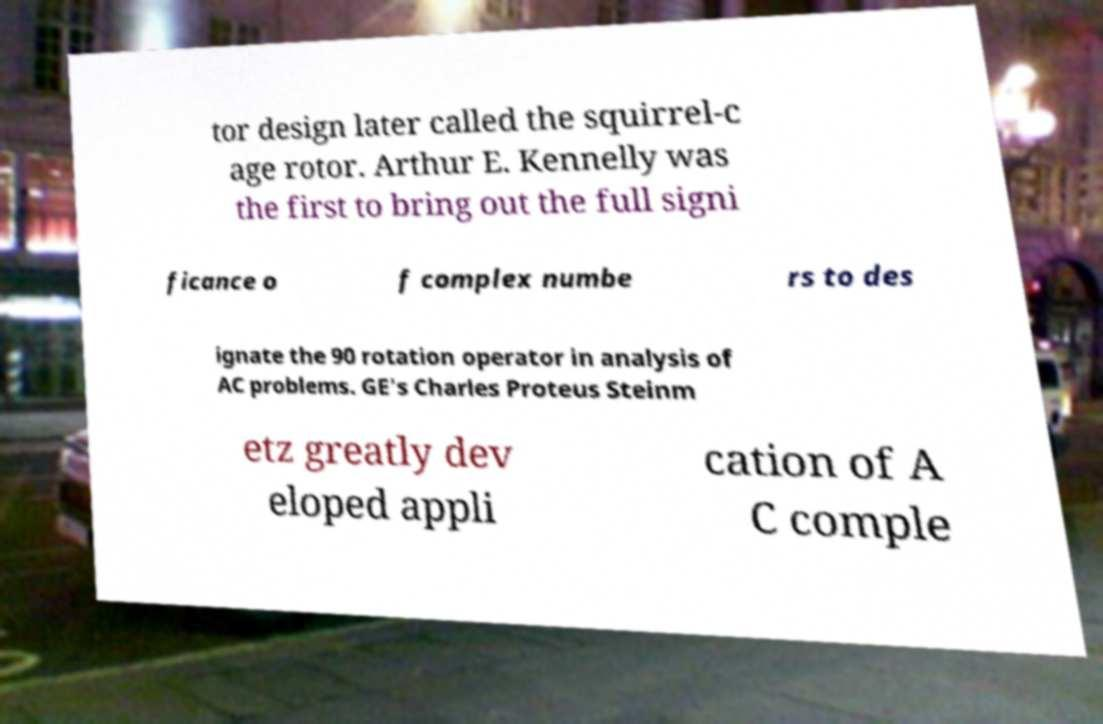Could you extract and type out the text from this image? tor design later called the squirrel-c age rotor. Arthur E. Kennelly was the first to bring out the full signi ficance o f complex numbe rs to des ignate the 90 rotation operator in analysis of AC problems. GE's Charles Proteus Steinm etz greatly dev eloped appli cation of A C comple 